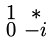<formula> <loc_0><loc_0><loc_500><loc_500>\begin{smallmatrix} 1 & * \\ 0 & - i \end{smallmatrix}</formula> 